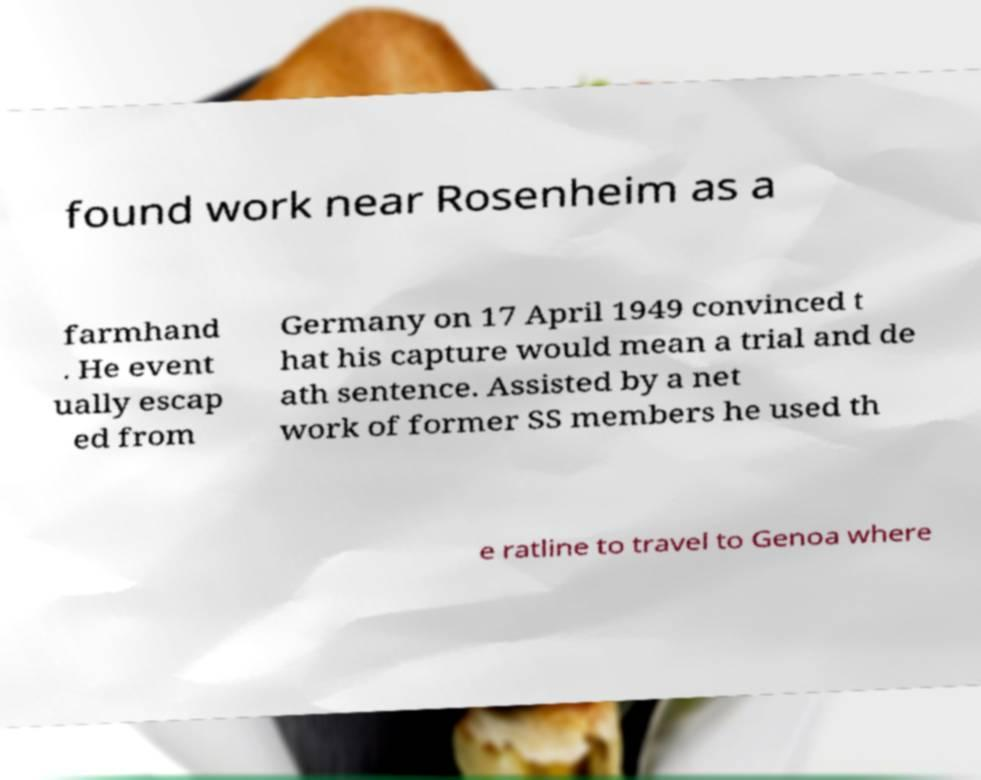Could you assist in decoding the text presented in this image and type it out clearly? found work near Rosenheim as a farmhand . He event ually escap ed from Germany on 17 April 1949 convinced t hat his capture would mean a trial and de ath sentence. Assisted by a net work of former SS members he used th e ratline to travel to Genoa where 